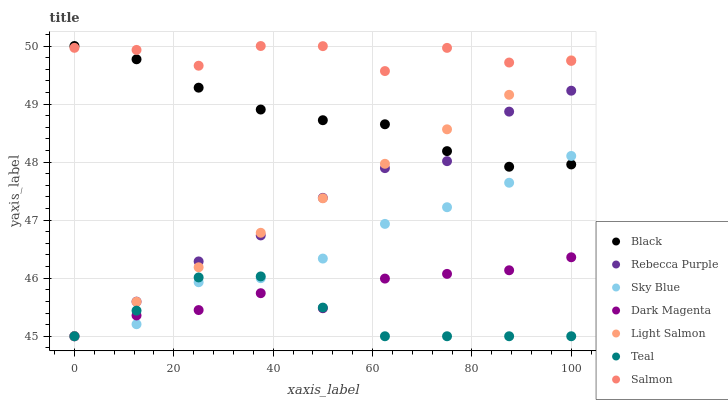Does Teal have the minimum area under the curve?
Answer yes or no. Yes. Does Salmon have the maximum area under the curve?
Answer yes or no. Yes. Does Dark Magenta have the minimum area under the curve?
Answer yes or no. No. Does Dark Magenta have the maximum area under the curve?
Answer yes or no. No. Is Light Salmon the smoothest?
Answer yes or no. Yes. Is Salmon the roughest?
Answer yes or no. Yes. Is Dark Magenta the smoothest?
Answer yes or no. No. Is Dark Magenta the roughest?
Answer yes or no. No. Does Light Salmon have the lowest value?
Answer yes or no. Yes. Does Salmon have the lowest value?
Answer yes or no. No. Does Black have the highest value?
Answer yes or no. Yes. Does Dark Magenta have the highest value?
Answer yes or no. No. Is Dark Magenta less than Salmon?
Answer yes or no. Yes. Is Salmon greater than Rebecca Purple?
Answer yes or no. Yes. Does Sky Blue intersect Black?
Answer yes or no. Yes. Is Sky Blue less than Black?
Answer yes or no. No. Is Sky Blue greater than Black?
Answer yes or no. No. Does Dark Magenta intersect Salmon?
Answer yes or no. No. 